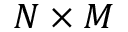<formula> <loc_0><loc_0><loc_500><loc_500>N \times M</formula> 